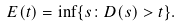<formula> <loc_0><loc_0><loc_500><loc_500>E ( t ) = \inf \{ s \colon D ( s ) > t \} .</formula> 